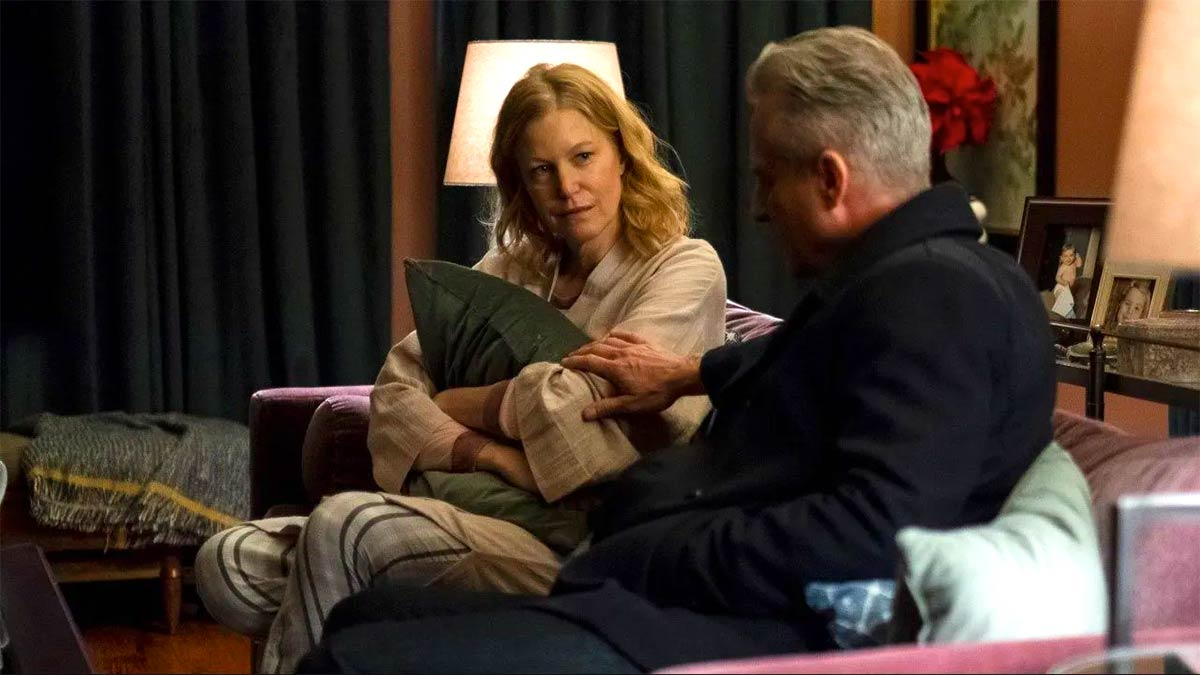Describe the mood and the emotions conveyed in the scene. The mood of the scene is contemplative and somewhat somber, with a touch of warmth and intimacy. The woman, holding a pillow, appears to be deep in thought or emotionally burdened, seeking comfort. The man beside her seems to be offering support and understanding, his hand gently placed on her arm indicating empathy and a strong emotional connection between the two. The soft lighting and cozy environment add to the overall feeling of intimacy and personal connection in the image. What could they be discussing? Given their body language and expressions, they might be discussing something deeply personal or challenging. The woman’s introspective demeanor and the man's attentive presence suggest a conversation that requires understanding and empathy. This could range from discussing a family matter, confronting a personal issue, to reminiscing about past experiences. The setting being intimate and homely suggests a private and meaningful dialogue. 